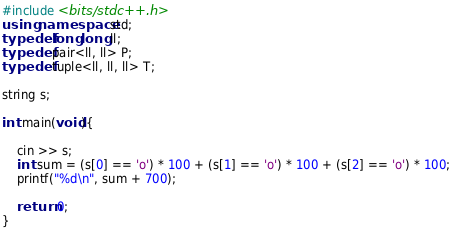<code> <loc_0><loc_0><loc_500><loc_500><_C++_>#include <bits/stdc++.h>
using namespace std;
typedef long long ll;
typedef pair<ll, ll> P;
typedef tuple<ll, ll, ll> T;

string s;

int main(void){
    
    cin >> s;
    int sum = (s[0] == 'o') * 100 + (s[1] == 'o') * 100 + (s[2] == 'o') * 100;
    printf("%d\n", sum + 700);
    
    return 0;
}</code> 